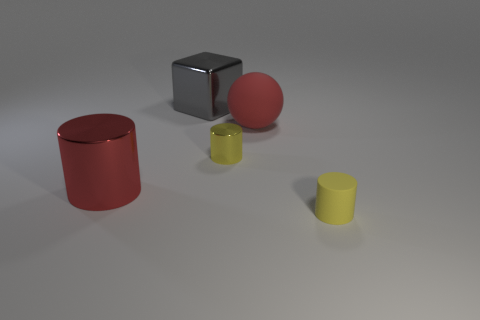Subtract all tiny yellow cylinders. How many cylinders are left? 1 Add 3 small gray metal spheres. How many objects exist? 8 Subtract all red cylinders. How many cylinders are left? 2 Subtract all balls. How many objects are left? 4 Subtract all gray blocks. How many yellow cylinders are left? 2 Add 3 small yellow shiny objects. How many small yellow shiny objects are left? 4 Add 1 big blue objects. How many big blue objects exist? 1 Subtract 0 brown cylinders. How many objects are left? 5 Subtract 1 cylinders. How many cylinders are left? 2 Subtract all green spheres. Subtract all cyan cubes. How many spheres are left? 1 